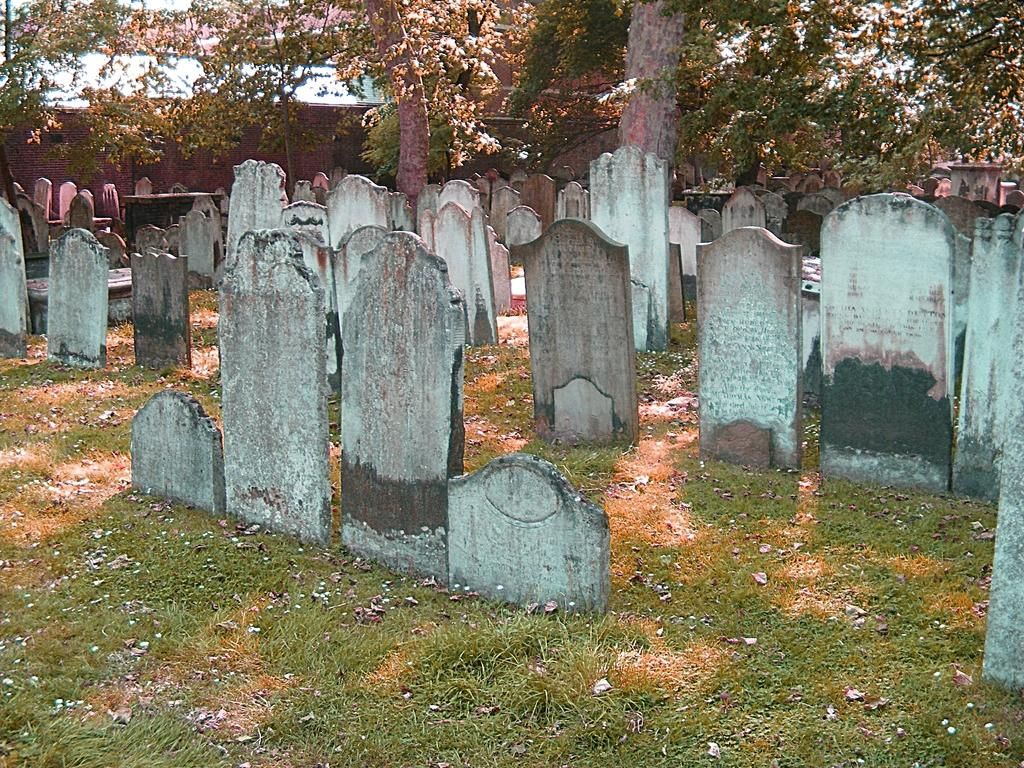What type of land is depicted in the image? There is a land in the image. What can be found on the land? There are headstones and trees on the land. What color is the canvas used for the headstones in the image? There is no canvas present in the image; the headstones are made of stone or other materials. 